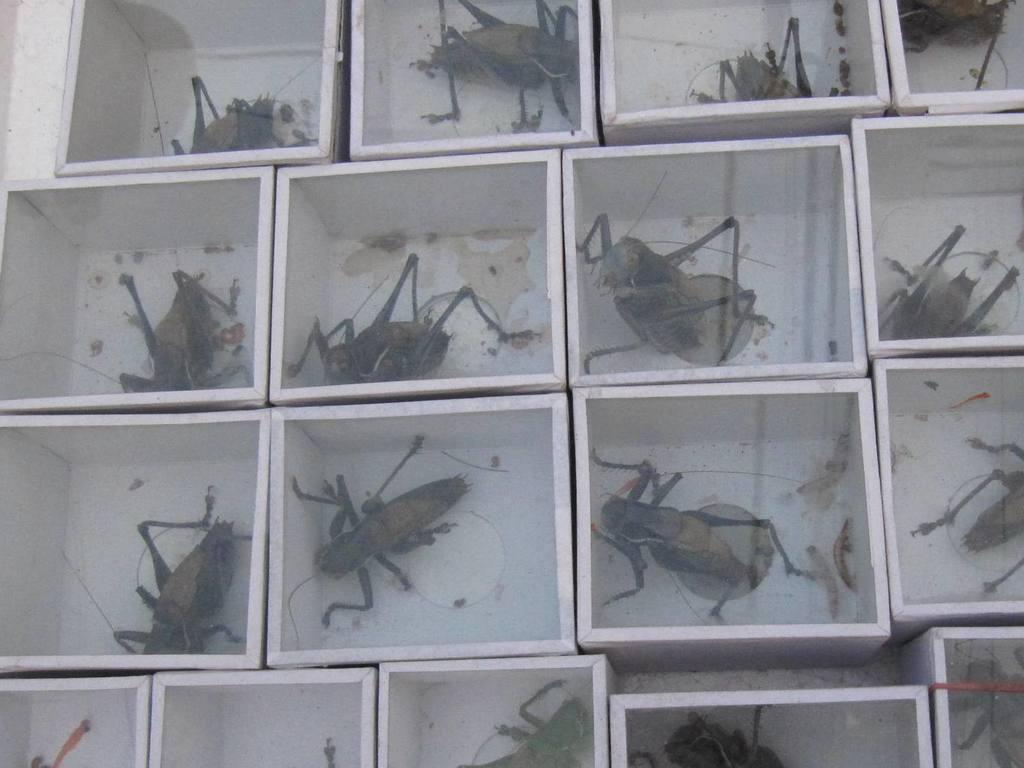What objects are present in the image? There are boxes in the image. What is inside each box? In each box, there is an insect. What type of chalk is being used to draw a curve on the boxes in the image? There is no chalk or curve present in the image; it only features boxes with insects inside. 